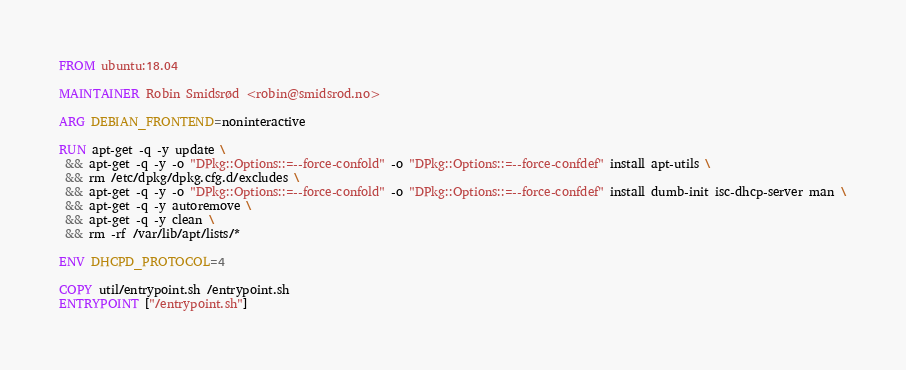Convert code to text. <code><loc_0><loc_0><loc_500><loc_500><_Dockerfile_>FROM ubuntu:18.04

MAINTAINER Robin Smidsrød <robin@smidsrod.no>

ARG DEBIAN_FRONTEND=noninteractive

RUN apt-get -q -y update \
 && apt-get -q -y -o "DPkg::Options::=--force-confold" -o "DPkg::Options::=--force-confdef" install apt-utils \
 && rm /etc/dpkg/dpkg.cfg.d/excludes \
 && apt-get -q -y -o "DPkg::Options::=--force-confold" -o "DPkg::Options::=--force-confdef" install dumb-init isc-dhcp-server man \
 && apt-get -q -y autoremove \
 && apt-get -q -y clean \
 && rm -rf /var/lib/apt/lists/*

ENV DHCPD_PROTOCOL=4

COPY util/entrypoint.sh /entrypoint.sh
ENTRYPOINT ["/entrypoint.sh"]
</code> 